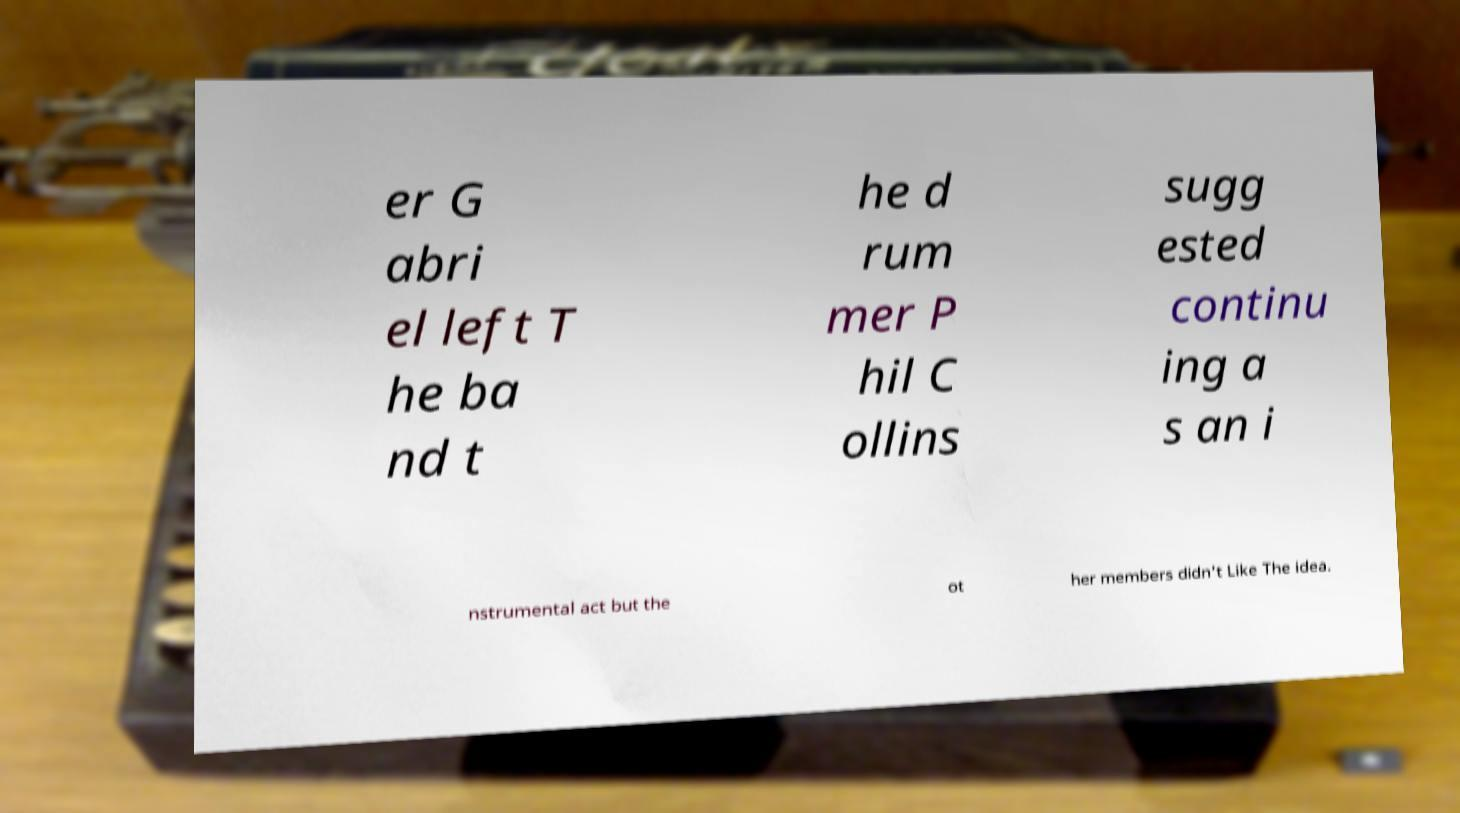Can you accurately transcribe the text from the provided image for me? er G abri el left T he ba nd t he d rum mer P hil C ollins sugg ested continu ing a s an i nstrumental act but the ot her members didn't Like The idea. 